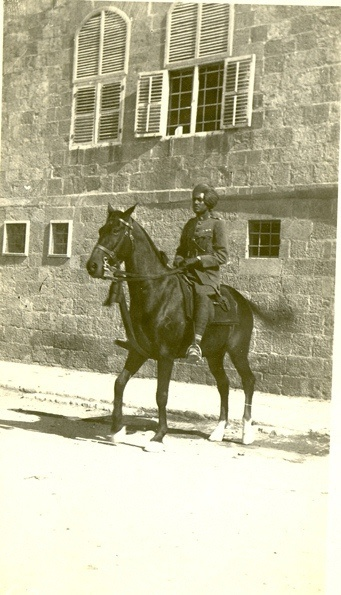Describe the objects in this image and their specific colors. I can see horse in ivory, darkgreen, and olive tones and people in ivory, darkgreen, and gray tones in this image. 